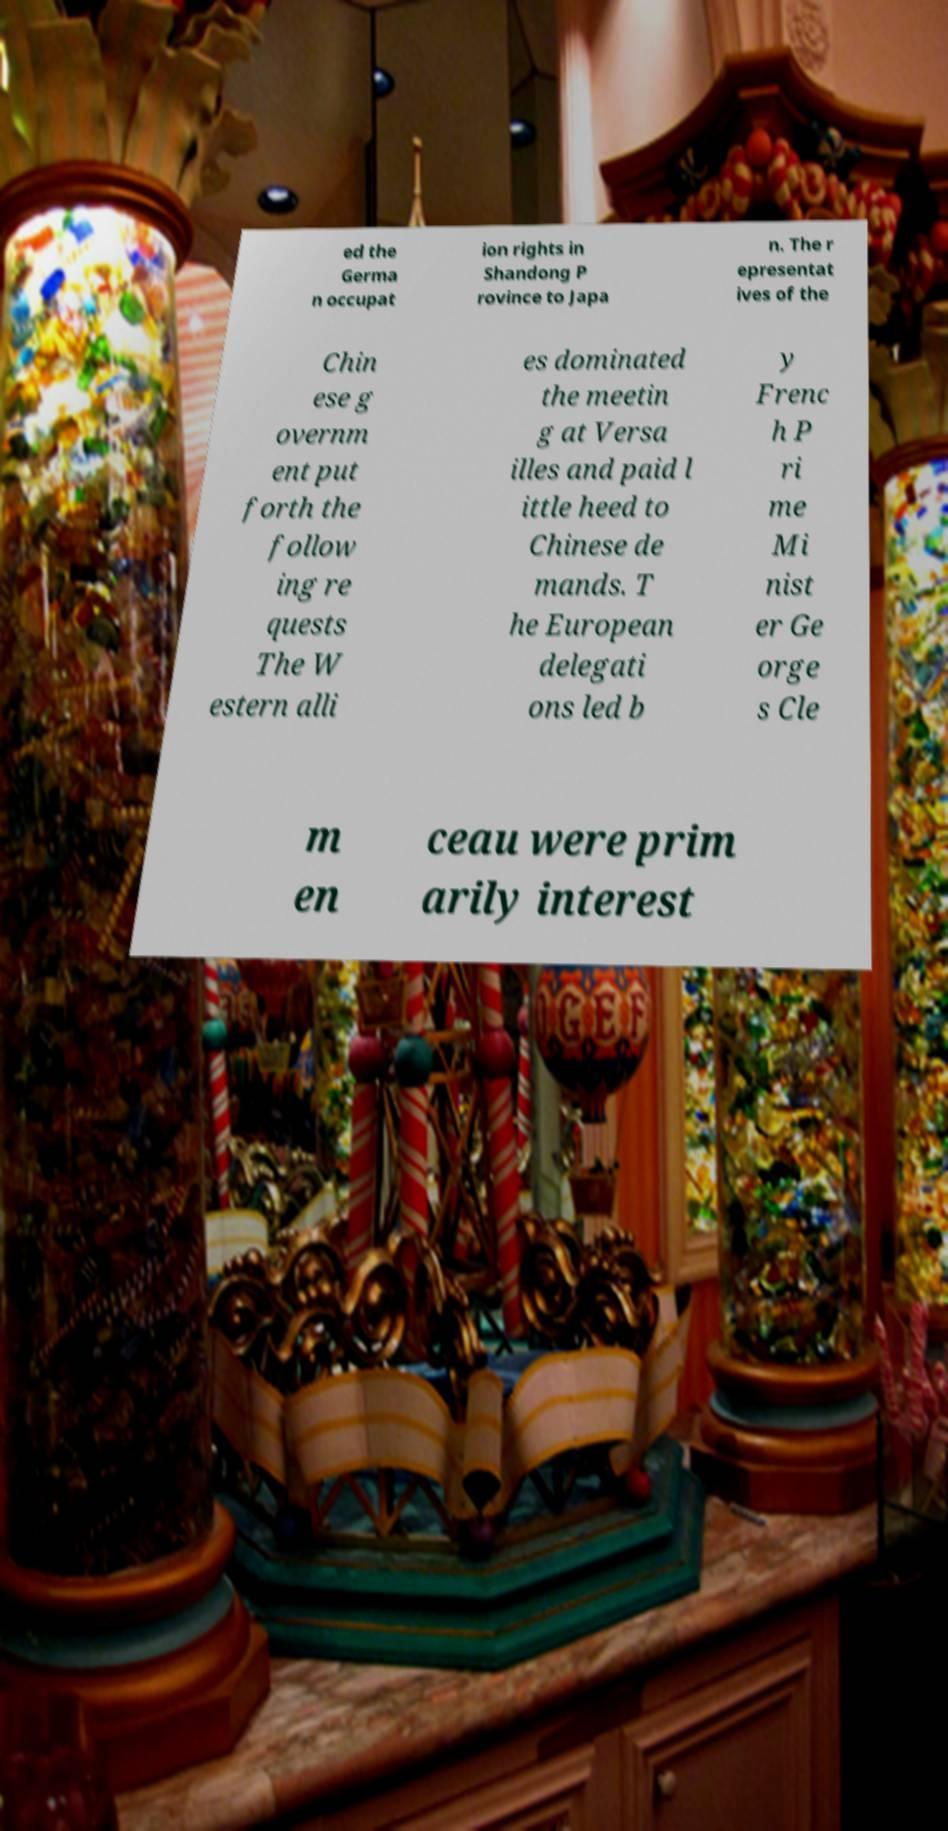Could you assist in decoding the text presented in this image and type it out clearly? ed the Germa n occupat ion rights in Shandong P rovince to Japa n. The r epresentat ives of the Chin ese g overnm ent put forth the follow ing re quests The W estern alli es dominated the meetin g at Versa illes and paid l ittle heed to Chinese de mands. T he European delegati ons led b y Frenc h P ri me Mi nist er Ge orge s Cle m en ceau were prim arily interest 